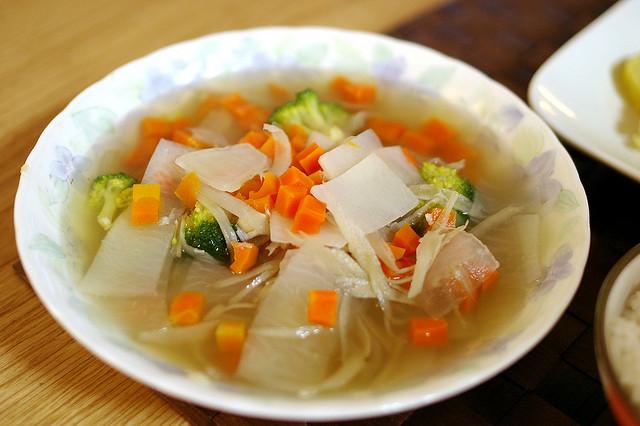What shape is the bowl?
Be succinct. Round. Was this food in a child's lunch box?
Quick response, please. No. What is the green leafy thing on top of the soup?
Keep it brief. Broccoli. Is this a tomato broth?
Give a very brief answer. No. What is the orange squares?
Answer briefly. Carrots. What is the consistency of the food in the bowl?
Write a very short answer. Soup. 